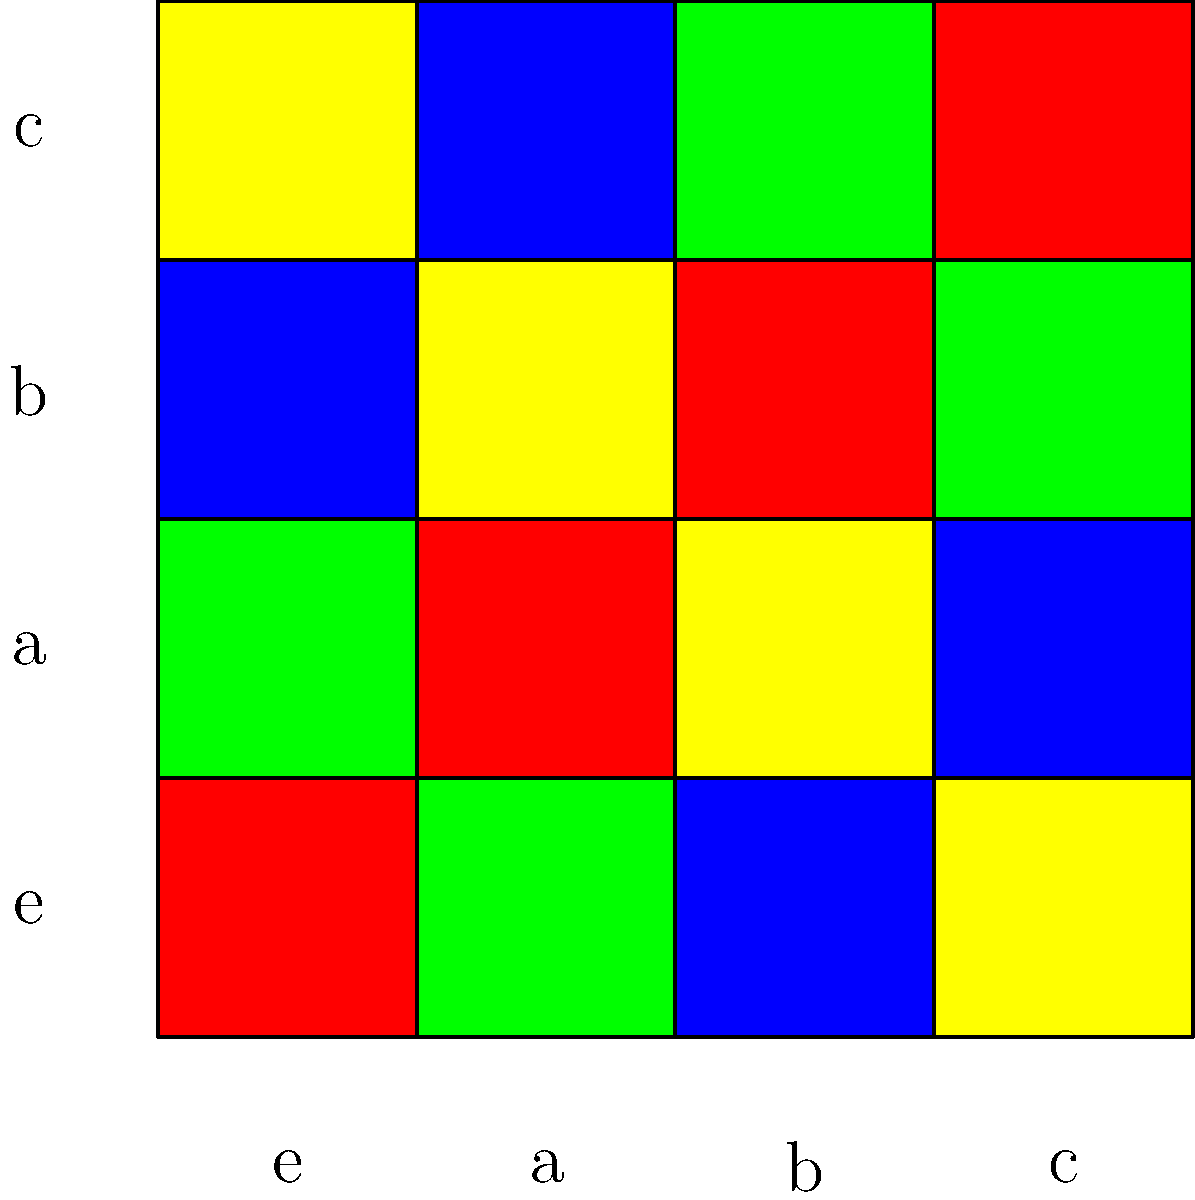Analiza la tabla de Cayley codificada por colores para el grupo $\{e,a,b,c\}$. ¿Cuál es el orden del elemento $b$ en este grupo? Para determinar el orden del elemento $b$ en este grupo, seguiremos estos pasos:

1) El orden de un elemento es el menor entero positivo $n$ tal que $b^n = e$, donde $e$ es el elemento identidad.

2) En la tabla de Cayley, el elemento identidad $e$ está representado por el color rojo.

3) Empezamos con $b$ (tercera fila/columna, color azul):
   - $b^1 = b$ (azul)
   - $b^2 = b \cdot b$ (intersección de la fila $b$ y la columna $b$) = $e$ (rojo)

4) Como $b^2 = e$, hemos encontrado el menor entero positivo $n$ que cumple $b^n = e$.

Por lo tanto, el orden del elemento $b$ es 2.
Answer: 2 